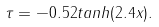<formula> <loc_0><loc_0><loc_500><loc_500>\tau = - 0 . 5 2 t a n h ( 2 . 4 x ) .</formula> 